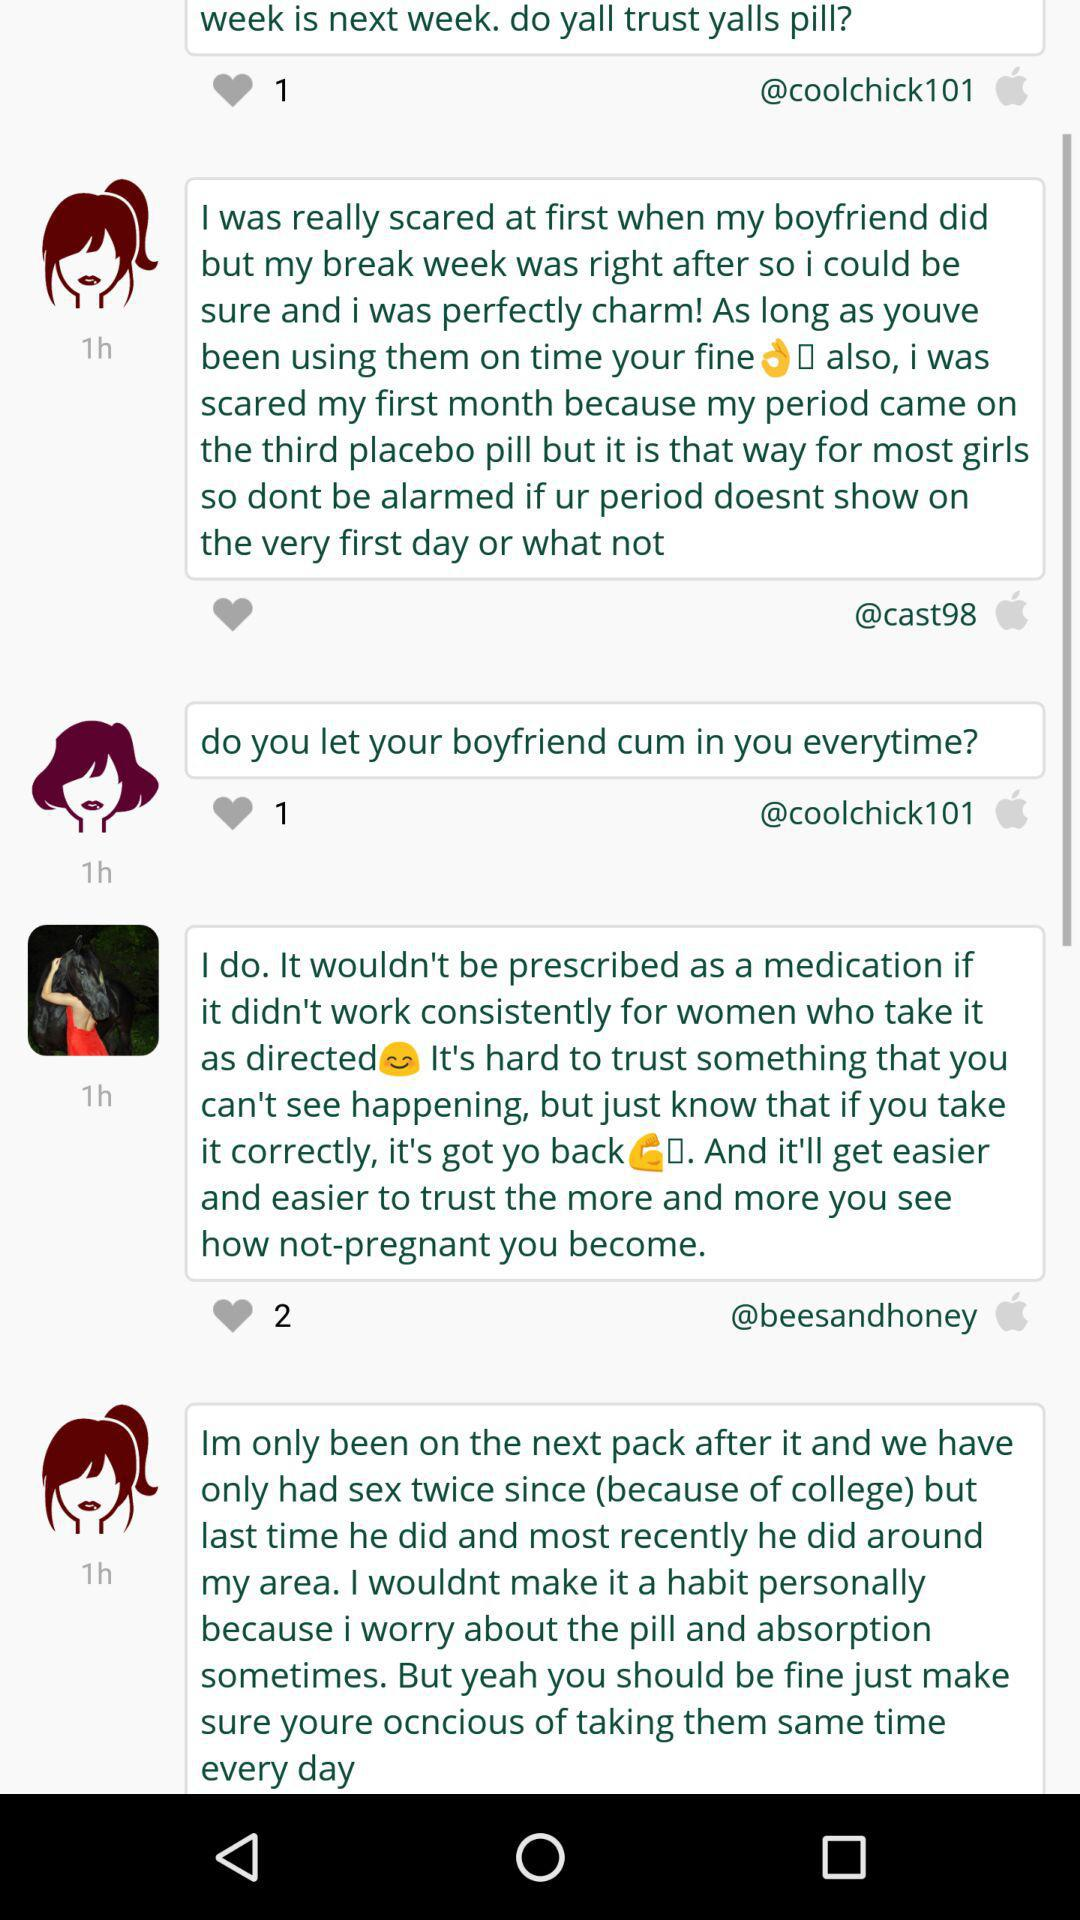What is the number of break days I have after my period? There are 9 break days you have after your period. 